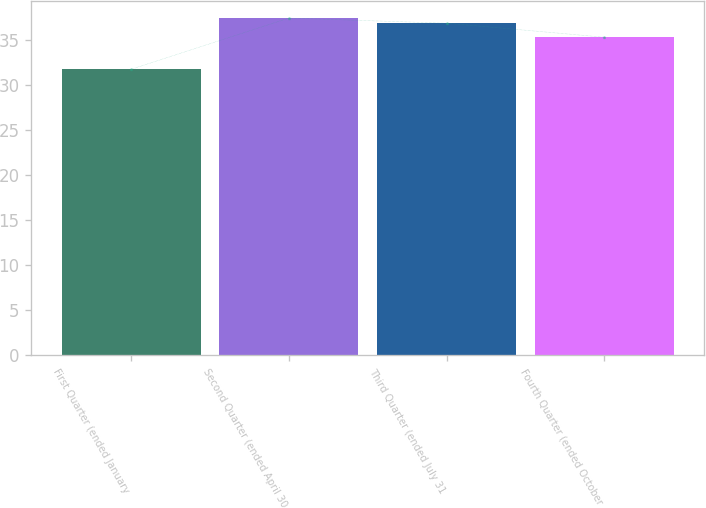<chart> <loc_0><loc_0><loc_500><loc_500><bar_chart><fcel>First Quarter (ended January<fcel>Second Quarter (ended April 30<fcel>Third Quarter (ended July 31<fcel>Fourth Quarter (ended October<nl><fcel>31.77<fcel>37.46<fcel>36.89<fcel>35.33<nl></chart> 